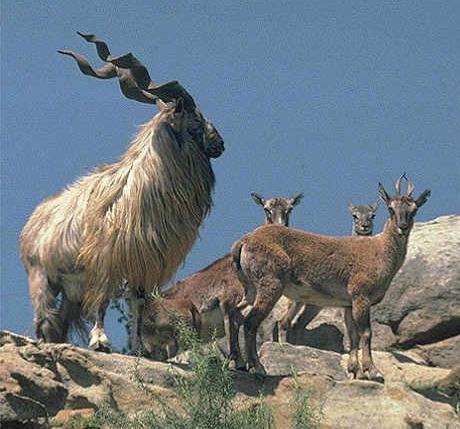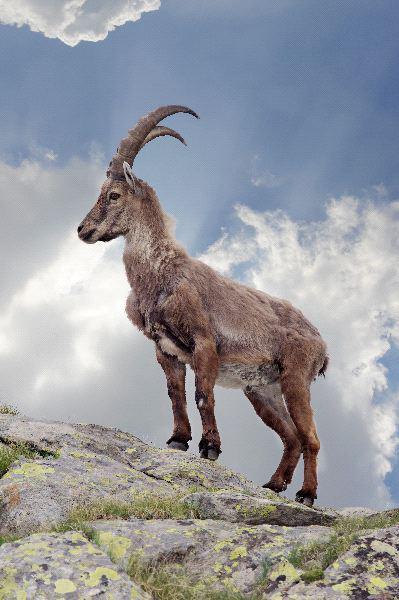The first image is the image on the left, the second image is the image on the right. For the images displayed, is the sentence "There are more than two animals." factually correct? Answer yes or no. Yes. 